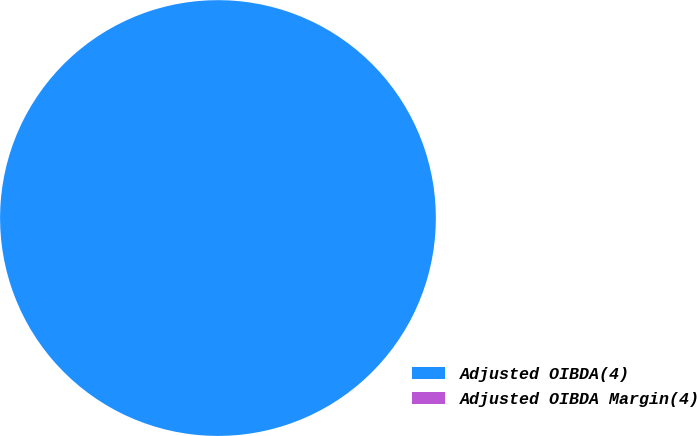Convert chart. <chart><loc_0><loc_0><loc_500><loc_500><pie_chart><fcel>Adjusted OIBDA(4)<fcel>Adjusted OIBDA Margin(4)<nl><fcel>100.0%<fcel>0.0%<nl></chart> 